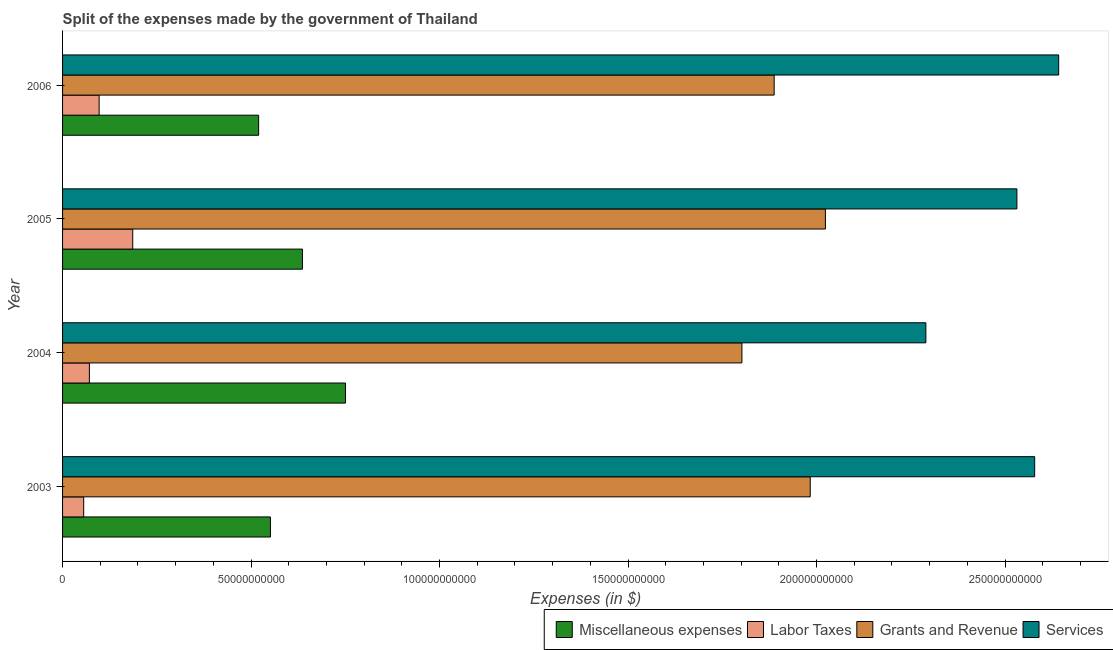How many different coloured bars are there?
Your answer should be compact. 4. Are the number of bars on each tick of the Y-axis equal?
Your response must be concise. Yes. How many bars are there on the 1st tick from the top?
Give a very brief answer. 4. What is the label of the 4th group of bars from the top?
Your answer should be compact. 2003. In how many cases, is the number of bars for a given year not equal to the number of legend labels?
Provide a short and direct response. 0. What is the amount spent on grants and revenue in 2004?
Your response must be concise. 1.80e+11. Across all years, what is the maximum amount spent on services?
Provide a succinct answer. 2.64e+11. Across all years, what is the minimum amount spent on grants and revenue?
Your answer should be very brief. 1.80e+11. In which year was the amount spent on labor taxes maximum?
Offer a terse response. 2005. In which year was the amount spent on services minimum?
Provide a short and direct response. 2004. What is the total amount spent on labor taxes in the graph?
Provide a short and direct response. 4.10e+1. What is the difference between the amount spent on services in 2003 and that in 2006?
Your answer should be compact. -6.37e+09. What is the difference between the amount spent on grants and revenue in 2004 and the amount spent on services in 2006?
Offer a terse response. -8.40e+1. What is the average amount spent on grants and revenue per year?
Ensure brevity in your answer.  1.92e+11. In the year 2005, what is the difference between the amount spent on labor taxes and amount spent on miscellaneous expenses?
Provide a short and direct response. -4.50e+1. What is the ratio of the amount spent on grants and revenue in 2003 to that in 2005?
Your answer should be compact. 0.98. Is the amount spent on services in 2003 less than that in 2004?
Provide a short and direct response. No. Is the difference between the amount spent on services in 2003 and 2006 greater than the difference between the amount spent on labor taxes in 2003 and 2006?
Your response must be concise. No. What is the difference between the highest and the second highest amount spent on grants and revenue?
Keep it short and to the point. 4.02e+09. What is the difference between the highest and the lowest amount spent on labor taxes?
Your answer should be very brief. 1.30e+1. In how many years, is the amount spent on labor taxes greater than the average amount spent on labor taxes taken over all years?
Your answer should be very brief. 1. Is it the case that in every year, the sum of the amount spent on grants and revenue and amount spent on labor taxes is greater than the sum of amount spent on services and amount spent on miscellaneous expenses?
Keep it short and to the point. Yes. What does the 4th bar from the top in 2005 represents?
Your response must be concise. Miscellaneous expenses. What does the 3rd bar from the bottom in 2004 represents?
Your answer should be compact. Grants and Revenue. How many bars are there?
Provide a short and direct response. 16. Are all the bars in the graph horizontal?
Ensure brevity in your answer.  Yes. How many years are there in the graph?
Offer a very short reply. 4. What is the difference between two consecutive major ticks on the X-axis?
Give a very brief answer. 5.00e+1. Does the graph contain any zero values?
Your answer should be very brief. No. Does the graph contain grids?
Provide a short and direct response. No. How many legend labels are there?
Keep it short and to the point. 4. What is the title of the graph?
Make the answer very short. Split of the expenses made by the government of Thailand. What is the label or title of the X-axis?
Your response must be concise. Expenses (in $). What is the label or title of the Y-axis?
Provide a short and direct response. Year. What is the Expenses (in $) of Miscellaneous expenses in 2003?
Make the answer very short. 5.51e+1. What is the Expenses (in $) of Labor Taxes in 2003?
Your response must be concise. 5.60e+09. What is the Expenses (in $) in Grants and Revenue in 2003?
Offer a terse response. 1.98e+11. What is the Expenses (in $) of Services in 2003?
Your answer should be very brief. 2.58e+11. What is the Expenses (in $) in Miscellaneous expenses in 2004?
Give a very brief answer. 7.50e+1. What is the Expenses (in $) in Labor Taxes in 2004?
Your response must be concise. 7.12e+09. What is the Expenses (in $) in Grants and Revenue in 2004?
Offer a terse response. 1.80e+11. What is the Expenses (in $) of Services in 2004?
Your answer should be compact. 2.29e+11. What is the Expenses (in $) in Miscellaneous expenses in 2005?
Your response must be concise. 6.36e+1. What is the Expenses (in $) of Labor Taxes in 2005?
Provide a succinct answer. 1.86e+1. What is the Expenses (in $) in Grants and Revenue in 2005?
Provide a succinct answer. 2.02e+11. What is the Expenses (in $) of Services in 2005?
Ensure brevity in your answer.  2.53e+11. What is the Expenses (in $) of Miscellaneous expenses in 2006?
Your response must be concise. 5.20e+1. What is the Expenses (in $) in Labor Taxes in 2006?
Offer a very short reply. 9.70e+09. What is the Expenses (in $) of Grants and Revenue in 2006?
Provide a short and direct response. 1.89e+11. What is the Expenses (in $) in Services in 2006?
Provide a succinct answer. 2.64e+11. Across all years, what is the maximum Expenses (in $) of Miscellaneous expenses?
Provide a short and direct response. 7.50e+1. Across all years, what is the maximum Expenses (in $) of Labor Taxes?
Provide a succinct answer. 1.86e+1. Across all years, what is the maximum Expenses (in $) in Grants and Revenue?
Ensure brevity in your answer.  2.02e+11. Across all years, what is the maximum Expenses (in $) in Services?
Provide a short and direct response. 2.64e+11. Across all years, what is the minimum Expenses (in $) in Miscellaneous expenses?
Provide a short and direct response. 5.20e+1. Across all years, what is the minimum Expenses (in $) in Labor Taxes?
Your response must be concise. 5.60e+09. Across all years, what is the minimum Expenses (in $) in Grants and Revenue?
Your answer should be compact. 1.80e+11. Across all years, what is the minimum Expenses (in $) of Services?
Your answer should be compact. 2.29e+11. What is the total Expenses (in $) of Miscellaneous expenses in the graph?
Ensure brevity in your answer.  2.46e+11. What is the total Expenses (in $) in Labor Taxes in the graph?
Provide a succinct answer. 4.10e+1. What is the total Expenses (in $) of Grants and Revenue in the graph?
Give a very brief answer. 7.70e+11. What is the total Expenses (in $) in Services in the graph?
Provide a succinct answer. 1.00e+12. What is the difference between the Expenses (in $) in Miscellaneous expenses in 2003 and that in 2004?
Your answer should be very brief. -1.99e+1. What is the difference between the Expenses (in $) of Labor Taxes in 2003 and that in 2004?
Your answer should be very brief. -1.51e+09. What is the difference between the Expenses (in $) of Grants and Revenue in 2003 and that in 2004?
Provide a short and direct response. 1.81e+1. What is the difference between the Expenses (in $) of Services in 2003 and that in 2004?
Provide a succinct answer. 2.89e+1. What is the difference between the Expenses (in $) of Miscellaneous expenses in 2003 and that in 2005?
Offer a terse response. -8.49e+09. What is the difference between the Expenses (in $) of Labor Taxes in 2003 and that in 2005?
Ensure brevity in your answer.  -1.30e+1. What is the difference between the Expenses (in $) of Grants and Revenue in 2003 and that in 2005?
Ensure brevity in your answer.  -4.02e+09. What is the difference between the Expenses (in $) in Services in 2003 and that in 2005?
Ensure brevity in your answer.  4.71e+09. What is the difference between the Expenses (in $) of Miscellaneous expenses in 2003 and that in 2006?
Keep it short and to the point. 3.13e+09. What is the difference between the Expenses (in $) in Labor Taxes in 2003 and that in 2006?
Give a very brief answer. -4.10e+09. What is the difference between the Expenses (in $) of Grants and Revenue in 2003 and that in 2006?
Keep it short and to the point. 9.57e+09. What is the difference between the Expenses (in $) of Services in 2003 and that in 2006?
Offer a very short reply. -6.37e+09. What is the difference between the Expenses (in $) in Miscellaneous expenses in 2004 and that in 2005?
Give a very brief answer. 1.14e+1. What is the difference between the Expenses (in $) of Labor Taxes in 2004 and that in 2005?
Give a very brief answer. -1.15e+1. What is the difference between the Expenses (in $) of Grants and Revenue in 2004 and that in 2005?
Your answer should be very brief. -2.21e+1. What is the difference between the Expenses (in $) in Services in 2004 and that in 2005?
Provide a short and direct response. -2.41e+1. What is the difference between the Expenses (in $) of Miscellaneous expenses in 2004 and that in 2006?
Offer a very short reply. 2.30e+1. What is the difference between the Expenses (in $) of Labor Taxes in 2004 and that in 2006?
Provide a succinct answer. -2.58e+09. What is the difference between the Expenses (in $) in Grants and Revenue in 2004 and that in 2006?
Provide a succinct answer. -8.55e+09. What is the difference between the Expenses (in $) in Services in 2004 and that in 2006?
Give a very brief answer. -3.52e+1. What is the difference between the Expenses (in $) of Miscellaneous expenses in 2005 and that in 2006?
Your answer should be compact. 1.16e+1. What is the difference between the Expenses (in $) of Labor Taxes in 2005 and that in 2006?
Your answer should be compact. 8.92e+09. What is the difference between the Expenses (in $) in Grants and Revenue in 2005 and that in 2006?
Your answer should be very brief. 1.36e+1. What is the difference between the Expenses (in $) in Services in 2005 and that in 2006?
Offer a very short reply. -1.11e+1. What is the difference between the Expenses (in $) of Miscellaneous expenses in 2003 and the Expenses (in $) of Labor Taxes in 2004?
Keep it short and to the point. 4.80e+1. What is the difference between the Expenses (in $) in Miscellaneous expenses in 2003 and the Expenses (in $) in Grants and Revenue in 2004?
Keep it short and to the point. -1.25e+11. What is the difference between the Expenses (in $) in Miscellaneous expenses in 2003 and the Expenses (in $) in Services in 2004?
Make the answer very short. -1.74e+11. What is the difference between the Expenses (in $) of Labor Taxes in 2003 and the Expenses (in $) of Grants and Revenue in 2004?
Give a very brief answer. -1.75e+11. What is the difference between the Expenses (in $) in Labor Taxes in 2003 and the Expenses (in $) in Services in 2004?
Give a very brief answer. -2.23e+11. What is the difference between the Expenses (in $) in Grants and Revenue in 2003 and the Expenses (in $) in Services in 2004?
Provide a short and direct response. -3.07e+1. What is the difference between the Expenses (in $) in Miscellaneous expenses in 2003 and the Expenses (in $) in Labor Taxes in 2005?
Provide a short and direct response. 3.65e+1. What is the difference between the Expenses (in $) in Miscellaneous expenses in 2003 and the Expenses (in $) in Grants and Revenue in 2005?
Keep it short and to the point. -1.47e+11. What is the difference between the Expenses (in $) of Miscellaneous expenses in 2003 and the Expenses (in $) of Services in 2005?
Offer a terse response. -1.98e+11. What is the difference between the Expenses (in $) in Labor Taxes in 2003 and the Expenses (in $) in Grants and Revenue in 2005?
Your answer should be compact. -1.97e+11. What is the difference between the Expenses (in $) in Labor Taxes in 2003 and the Expenses (in $) in Services in 2005?
Your answer should be compact. -2.48e+11. What is the difference between the Expenses (in $) of Grants and Revenue in 2003 and the Expenses (in $) of Services in 2005?
Give a very brief answer. -5.48e+1. What is the difference between the Expenses (in $) of Miscellaneous expenses in 2003 and the Expenses (in $) of Labor Taxes in 2006?
Provide a succinct answer. 4.54e+1. What is the difference between the Expenses (in $) in Miscellaneous expenses in 2003 and the Expenses (in $) in Grants and Revenue in 2006?
Offer a terse response. -1.34e+11. What is the difference between the Expenses (in $) of Miscellaneous expenses in 2003 and the Expenses (in $) of Services in 2006?
Ensure brevity in your answer.  -2.09e+11. What is the difference between the Expenses (in $) of Labor Taxes in 2003 and the Expenses (in $) of Grants and Revenue in 2006?
Your answer should be compact. -1.83e+11. What is the difference between the Expenses (in $) of Labor Taxes in 2003 and the Expenses (in $) of Services in 2006?
Give a very brief answer. -2.59e+11. What is the difference between the Expenses (in $) in Grants and Revenue in 2003 and the Expenses (in $) in Services in 2006?
Offer a terse response. -6.59e+1. What is the difference between the Expenses (in $) of Miscellaneous expenses in 2004 and the Expenses (in $) of Labor Taxes in 2005?
Keep it short and to the point. 5.64e+1. What is the difference between the Expenses (in $) of Miscellaneous expenses in 2004 and the Expenses (in $) of Grants and Revenue in 2005?
Make the answer very short. -1.27e+11. What is the difference between the Expenses (in $) of Miscellaneous expenses in 2004 and the Expenses (in $) of Services in 2005?
Provide a succinct answer. -1.78e+11. What is the difference between the Expenses (in $) in Labor Taxes in 2004 and the Expenses (in $) in Grants and Revenue in 2005?
Provide a succinct answer. -1.95e+11. What is the difference between the Expenses (in $) of Labor Taxes in 2004 and the Expenses (in $) of Services in 2005?
Your response must be concise. -2.46e+11. What is the difference between the Expenses (in $) of Grants and Revenue in 2004 and the Expenses (in $) of Services in 2005?
Provide a succinct answer. -7.29e+1. What is the difference between the Expenses (in $) in Miscellaneous expenses in 2004 and the Expenses (in $) in Labor Taxes in 2006?
Make the answer very short. 6.53e+1. What is the difference between the Expenses (in $) of Miscellaneous expenses in 2004 and the Expenses (in $) of Grants and Revenue in 2006?
Give a very brief answer. -1.14e+11. What is the difference between the Expenses (in $) in Miscellaneous expenses in 2004 and the Expenses (in $) in Services in 2006?
Your response must be concise. -1.89e+11. What is the difference between the Expenses (in $) of Labor Taxes in 2004 and the Expenses (in $) of Grants and Revenue in 2006?
Your response must be concise. -1.82e+11. What is the difference between the Expenses (in $) in Labor Taxes in 2004 and the Expenses (in $) in Services in 2006?
Your response must be concise. -2.57e+11. What is the difference between the Expenses (in $) in Grants and Revenue in 2004 and the Expenses (in $) in Services in 2006?
Make the answer very short. -8.40e+1. What is the difference between the Expenses (in $) of Miscellaneous expenses in 2005 and the Expenses (in $) of Labor Taxes in 2006?
Your answer should be compact. 5.39e+1. What is the difference between the Expenses (in $) of Miscellaneous expenses in 2005 and the Expenses (in $) of Grants and Revenue in 2006?
Ensure brevity in your answer.  -1.25e+11. What is the difference between the Expenses (in $) of Miscellaneous expenses in 2005 and the Expenses (in $) of Services in 2006?
Your response must be concise. -2.01e+11. What is the difference between the Expenses (in $) of Labor Taxes in 2005 and the Expenses (in $) of Grants and Revenue in 2006?
Your answer should be very brief. -1.70e+11. What is the difference between the Expenses (in $) in Labor Taxes in 2005 and the Expenses (in $) in Services in 2006?
Offer a very short reply. -2.46e+11. What is the difference between the Expenses (in $) of Grants and Revenue in 2005 and the Expenses (in $) of Services in 2006?
Provide a succinct answer. -6.19e+1. What is the average Expenses (in $) in Miscellaneous expenses per year?
Give a very brief answer. 6.15e+1. What is the average Expenses (in $) of Labor Taxes per year?
Your response must be concise. 1.03e+1. What is the average Expenses (in $) in Grants and Revenue per year?
Provide a short and direct response. 1.92e+11. What is the average Expenses (in $) of Services per year?
Make the answer very short. 2.51e+11. In the year 2003, what is the difference between the Expenses (in $) of Miscellaneous expenses and Expenses (in $) of Labor Taxes?
Keep it short and to the point. 4.95e+1. In the year 2003, what is the difference between the Expenses (in $) in Miscellaneous expenses and Expenses (in $) in Grants and Revenue?
Provide a succinct answer. -1.43e+11. In the year 2003, what is the difference between the Expenses (in $) in Miscellaneous expenses and Expenses (in $) in Services?
Ensure brevity in your answer.  -2.03e+11. In the year 2003, what is the difference between the Expenses (in $) of Labor Taxes and Expenses (in $) of Grants and Revenue?
Your answer should be compact. -1.93e+11. In the year 2003, what is the difference between the Expenses (in $) in Labor Taxes and Expenses (in $) in Services?
Offer a very short reply. -2.52e+11. In the year 2003, what is the difference between the Expenses (in $) in Grants and Revenue and Expenses (in $) in Services?
Make the answer very short. -5.95e+1. In the year 2004, what is the difference between the Expenses (in $) of Miscellaneous expenses and Expenses (in $) of Labor Taxes?
Make the answer very short. 6.79e+1. In the year 2004, what is the difference between the Expenses (in $) in Miscellaneous expenses and Expenses (in $) in Grants and Revenue?
Make the answer very short. -1.05e+11. In the year 2004, what is the difference between the Expenses (in $) of Miscellaneous expenses and Expenses (in $) of Services?
Give a very brief answer. -1.54e+11. In the year 2004, what is the difference between the Expenses (in $) of Labor Taxes and Expenses (in $) of Grants and Revenue?
Your response must be concise. -1.73e+11. In the year 2004, what is the difference between the Expenses (in $) in Labor Taxes and Expenses (in $) in Services?
Keep it short and to the point. -2.22e+11. In the year 2004, what is the difference between the Expenses (in $) of Grants and Revenue and Expenses (in $) of Services?
Offer a very short reply. -4.88e+1. In the year 2005, what is the difference between the Expenses (in $) in Miscellaneous expenses and Expenses (in $) in Labor Taxes?
Your answer should be compact. 4.50e+1. In the year 2005, what is the difference between the Expenses (in $) in Miscellaneous expenses and Expenses (in $) in Grants and Revenue?
Provide a short and direct response. -1.39e+11. In the year 2005, what is the difference between the Expenses (in $) in Miscellaneous expenses and Expenses (in $) in Services?
Make the answer very short. -1.90e+11. In the year 2005, what is the difference between the Expenses (in $) in Labor Taxes and Expenses (in $) in Grants and Revenue?
Ensure brevity in your answer.  -1.84e+11. In the year 2005, what is the difference between the Expenses (in $) of Labor Taxes and Expenses (in $) of Services?
Offer a terse response. -2.35e+11. In the year 2005, what is the difference between the Expenses (in $) of Grants and Revenue and Expenses (in $) of Services?
Offer a very short reply. -5.08e+1. In the year 2006, what is the difference between the Expenses (in $) in Miscellaneous expenses and Expenses (in $) in Labor Taxes?
Your response must be concise. 4.23e+1. In the year 2006, what is the difference between the Expenses (in $) in Miscellaneous expenses and Expenses (in $) in Grants and Revenue?
Give a very brief answer. -1.37e+11. In the year 2006, what is the difference between the Expenses (in $) in Miscellaneous expenses and Expenses (in $) in Services?
Offer a very short reply. -2.12e+11. In the year 2006, what is the difference between the Expenses (in $) of Labor Taxes and Expenses (in $) of Grants and Revenue?
Provide a short and direct response. -1.79e+11. In the year 2006, what is the difference between the Expenses (in $) in Labor Taxes and Expenses (in $) in Services?
Offer a terse response. -2.55e+11. In the year 2006, what is the difference between the Expenses (in $) of Grants and Revenue and Expenses (in $) of Services?
Provide a succinct answer. -7.55e+1. What is the ratio of the Expenses (in $) in Miscellaneous expenses in 2003 to that in 2004?
Make the answer very short. 0.73. What is the ratio of the Expenses (in $) of Labor Taxes in 2003 to that in 2004?
Provide a short and direct response. 0.79. What is the ratio of the Expenses (in $) in Grants and Revenue in 2003 to that in 2004?
Provide a short and direct response. 1.1. What is the ratio of the Expenses (in $) of Services in 2003 to that in 2004?
Your response must be concise. 1.13. What is the ratio of the Expenses (in $) of Miscellaneous expenses in 2003 to that in 2005?
Give a very brief answer. 0.87. What is the ratio of the Expenses (in $) of Labor Taxes in 2003 to that in 2005?
Offer a very short reply. 0.3. What is the ratio of the Expenses (in $) in Grants and Revenue in 2003 to that in 2005?
Your response must be concise. 0.98. What is the ratio of the Expenses (in $) of Services in 2003 to that in 2005?
Your answer should be very brief. 1.02. What is the ratio of the Expenses (in $) in Miscellaneous expenses in 2003 to that in 2006?
Your response must be concise. 1.06. What is the ratio of the Expenses (in $) of Labor Taxes in 2003 to that in 2006?
Your response must be concise. 0.58. What is the ratio of the Expenses (in $) in Grants and Revenue in 2003 to that in 2006?
Your response must be concise. 1.05. What is the ratio of the Expenses (in $) in Services in 2003 to that in 2006?
Offer a very short reply. 0.98. What is the ratio of the Expenses (in $) in Miscellaneous expenses in 2004 to that in 2005?
Give a very brief answer. 1.18. What is the ratio of the Expenses (in $) of Labor Taxes in 2004 to that in 2005?
Your response must be concise. 0.38. What is the ratio of the Expenses (in $) of Grants and Revenue in 2004 to that in 2005?
Ensure brevity in your answer.  0.89. What is the ratio of the Expenses (in $) of Services in 2004 to that in 2005?
Your answer should be compact. 0.9. What is the ratio of the Expenses (in $) in Miscellaneous expenses in 2004 to that in 2006?
Give a very brief answer. 1.44. What is the ratio of the Expenses (in $) in Labor Taxes in 2004 to that in 2006?
Your answer should be compact. 0.73. What is the ratio of the Expenses (in $) of Grants and Revenue in 2004 to that in 2006?
Provide a short and direct response. 0.95. What is the ratio of the Expenses (in $) in Services in 2004 to that in 2006?
Provide a succinct answer. 0.87. What is the ratio of the Expenses (in $) of Miscellaneous expenses in 2005 to that in 2006?
Ensure brevity in your answer.  1.22. What is the ratio of the Expenses (in $) of Labor Taxes in 2005 to that in 2006?
Your answer should be compact. 1.92. What is the ratio of the Expenses (in $) of Grants and Revenue in 2005 to that in 2006?
Provide a succinct answer. 1.07. What is the ratio of the Expenses (in $) in Services in 2005 to that in 2006?
Keep it short and to the point. 0.96. What is the difference between the highest and the second highest Expenses (in $) of Miscellaneous expenses?
Give a very brief answer. 1.14e+1. What is the difference between the highest and the second highest Expenses (in $) in Labor Taxes?
Your response must be concise. 8.92e+09. What is the difference between the highest and the second highest Expenses (in $) in Grants and Revenue?
Offer a very short reply. 4.02e+09. What is the difference between the highest and the second highest Expenses (in $) of Services?
Ensure brevity in your answer.  6.37e+09. What is the difference between the highest and the lowest Expenses (in $) of Miscellaneous expenses?
Your response must be concise. 2.30e+1. What is the difference between the highest and the lowest Expenses (in $) of Labor Taxes?
Make the answer very short. 1.30e+1. What is the difference between the highest and the lowest Expenses (in $) in Grants and Revenue?
Provide a succinct answer. 2.21e+1. What is the difference between the highest and the lowest Expenses (in $) in Services?
Offer a terse response. 3.52e+1. 